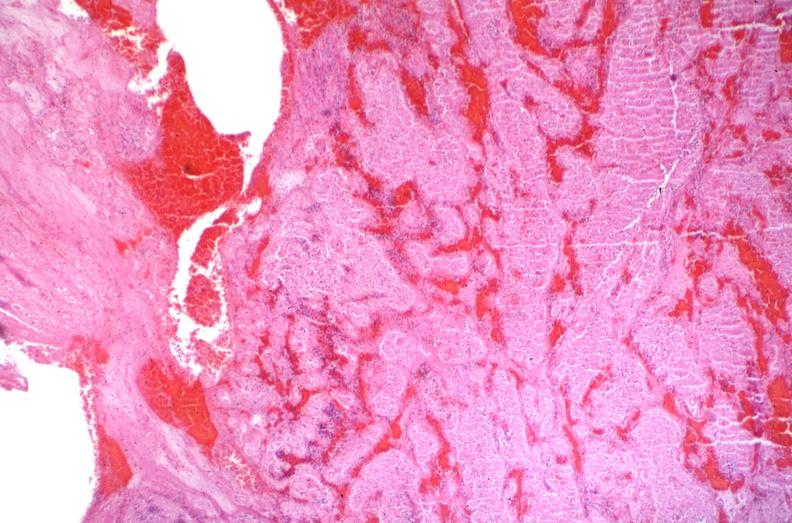does very good example show sickle cell disease, thrombus?
Answer the question using a single word or phrase. No 